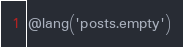Convert code to text. <code><loc_0><loc_0><loc_500><loc_500><_PHP_>@lang('posts.empty')
</code> 